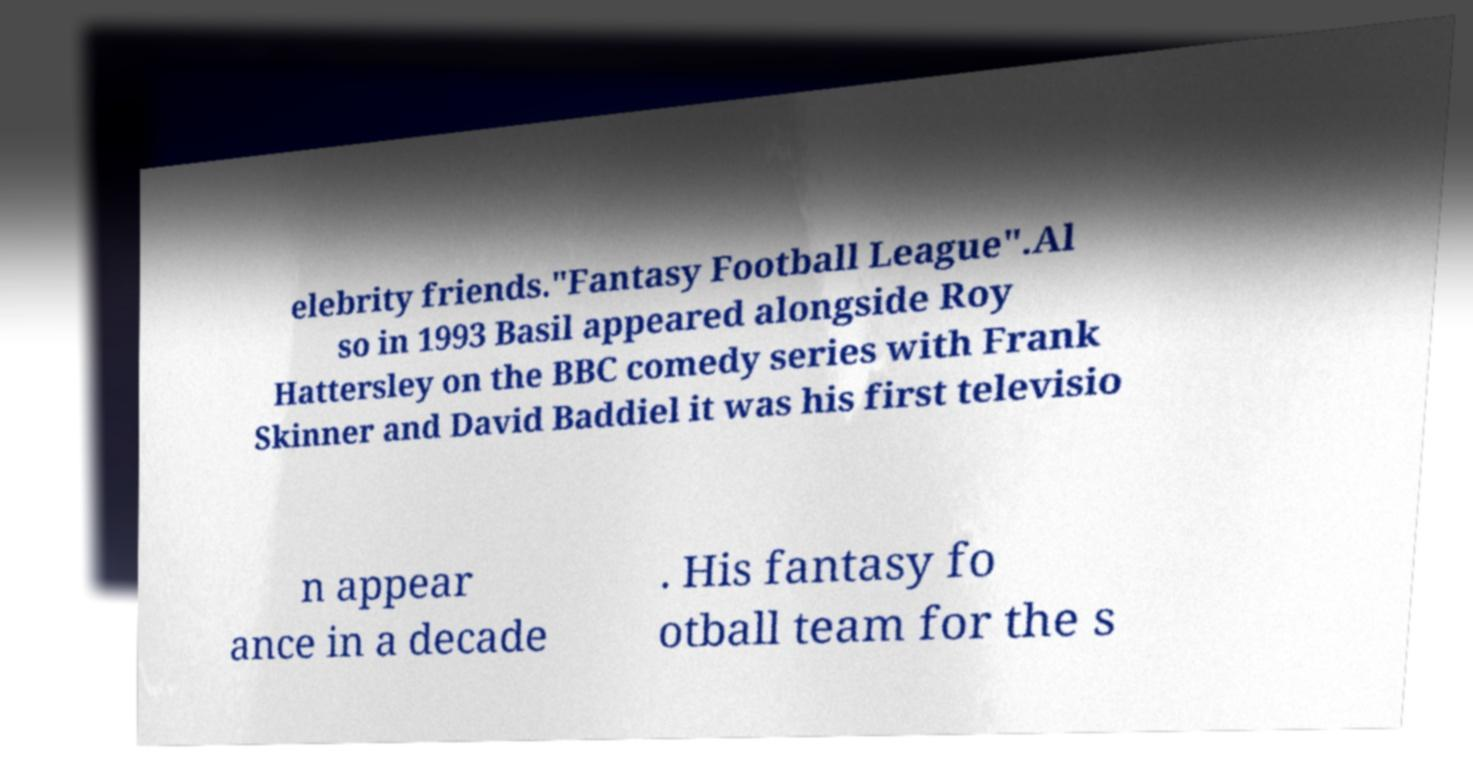Can you read and provide the text displayed in the image?This photo seems to have some interesting text. Can you extract and type it out for me? elebrity friends."Fantasy Football League".Al so in 1993 Basil appeared alongside Roy Hattersley on the BBC comedy series with Frank Skinner and David Baddiel it was his first televisio n appear ance in a decade . His fantasy fo otball team for the s 